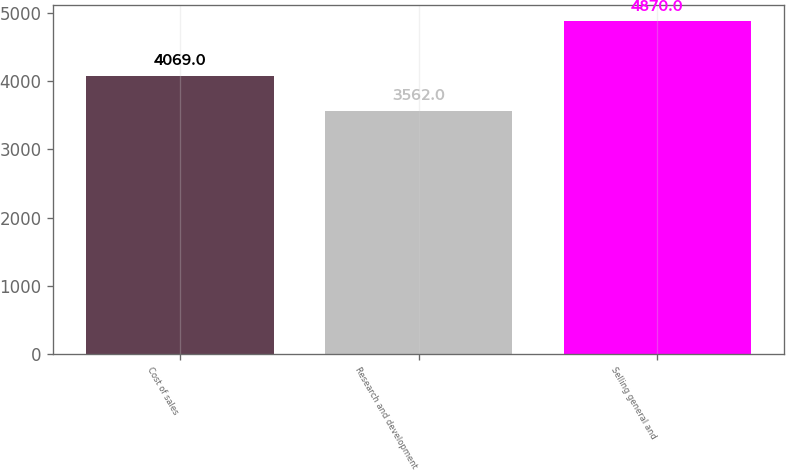Convert chart to OTSL. <chart><loc_0><loc_0><loc_500><loc_500><bar_chart><fcel>Cost of sales<fcel>Research and development<fcel>Selling general and<nl><fcel>4069<fcel>3562<fcel>4870<nl></chart> 